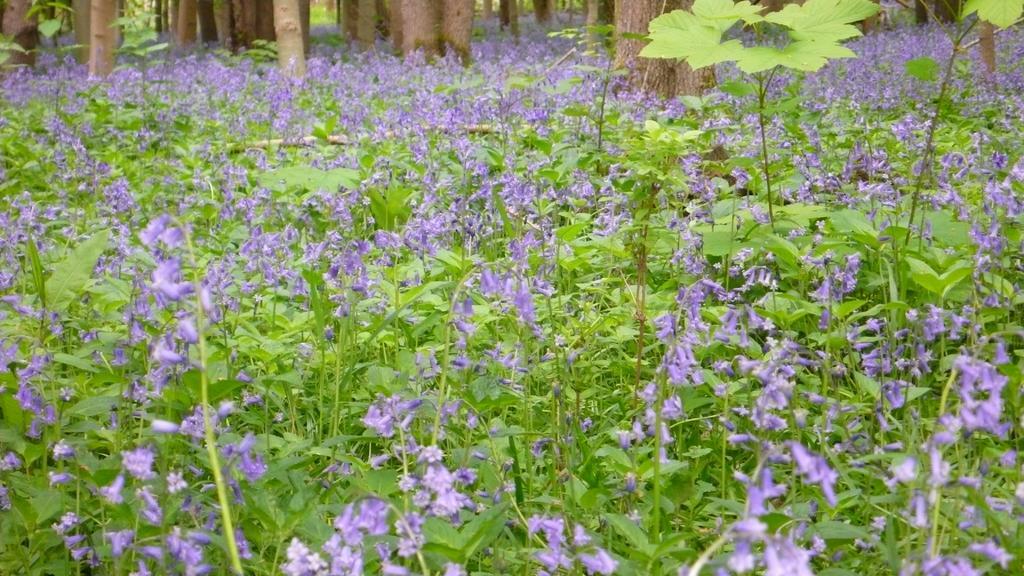In one or two sentences, can you explain what this image depicts? In this image we can see a group of plants with flowers. On the backside we can see the bark of the trees. 